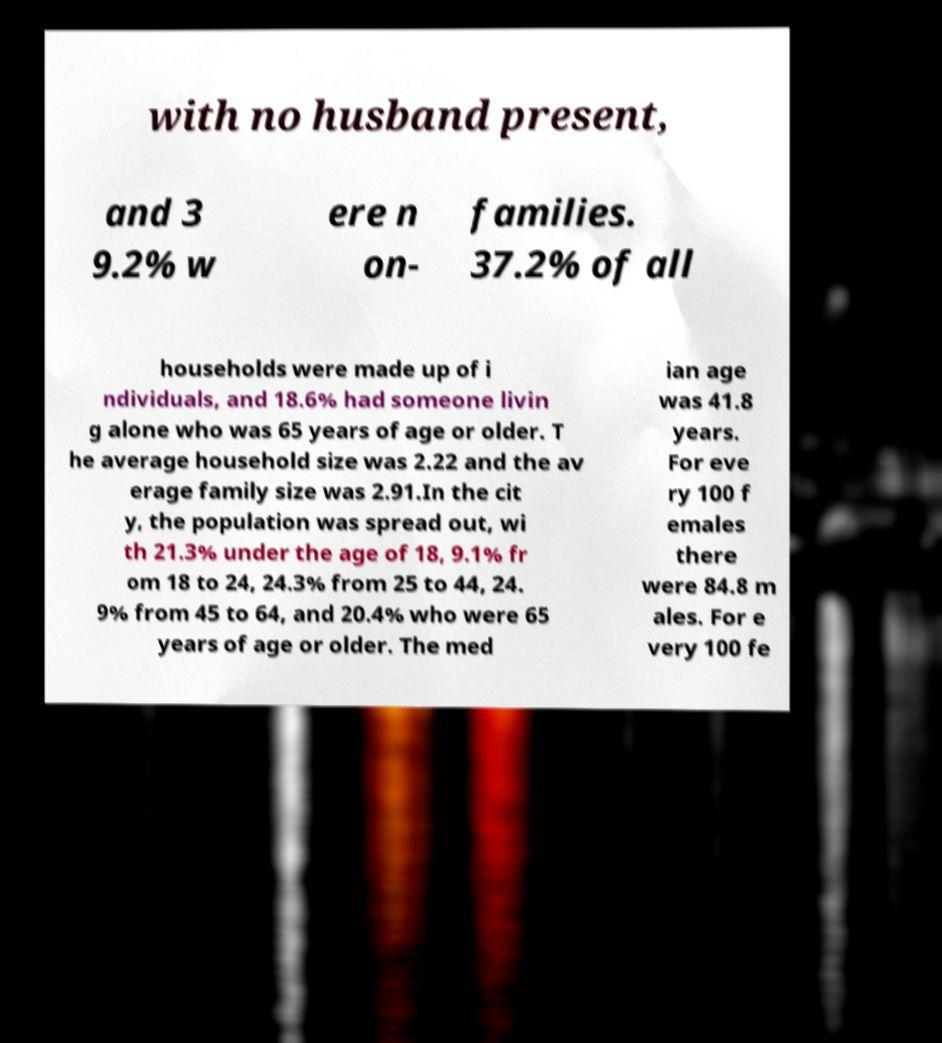Can you read and provide the text displayed in the image?This photo seems to have some interesting text. Can you extract and type it out for me? with no husband present, and 3 9.2% w ere n on- families. 37.2% of all households were made up of i ndividuals, and 18.6% had someone livin g alone who was 65 years of age or older. T he average household size was 2.22 and the av erage family size was 2.91.In the cit y, the population was spread out, wi th 21.3% under the age of 18, 9.1% fr om 18 to 24, 24.3% from 25 to 44, 24. 9% from 45 to 64, and 20.4% who were 65 years of age or older. The med ian age was 41.8 years. For eve ry 100 f emales there were 84.8 m ales. For e very 100 fe 